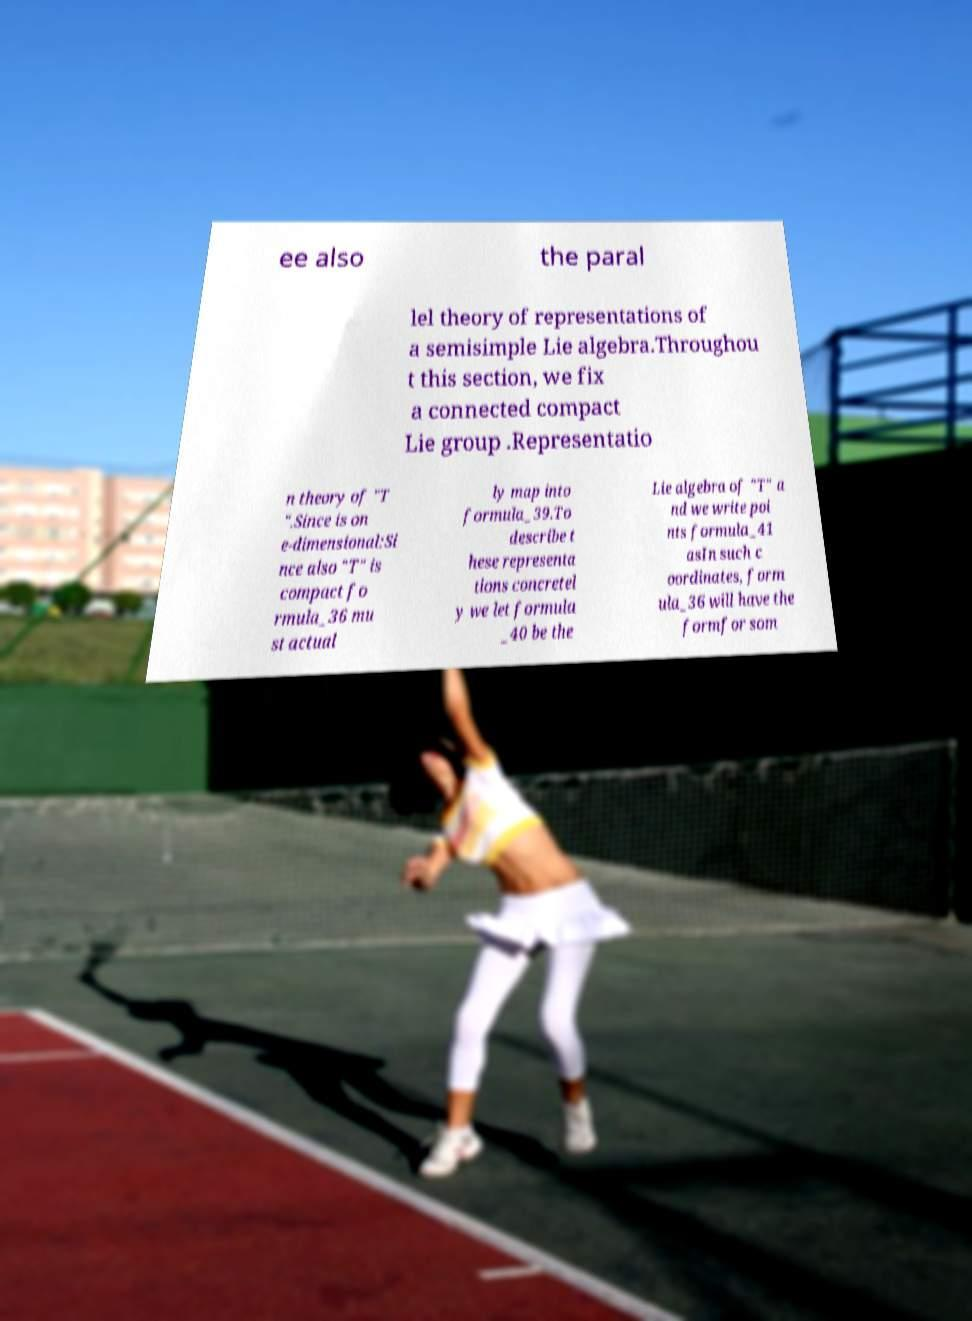Could you assist in decoding the text presented in this image and type it out clearly? ee also the paral lel theory of representations of a semisimple Lie algebra.Throughou t this section, we fix a connected compact Lie group .Representatio n theory of "T ".Since is on e-dimensional:Si nce also "T" is compact fo rmula_36 mu st actual ly map into formula_39.To describe t hese representa tions concretel y we let formula _40 be the Lie algebra of "T" a nd we write poi nts formula_41 asIn such c oordinates, form ula_36 will have the formfor som 